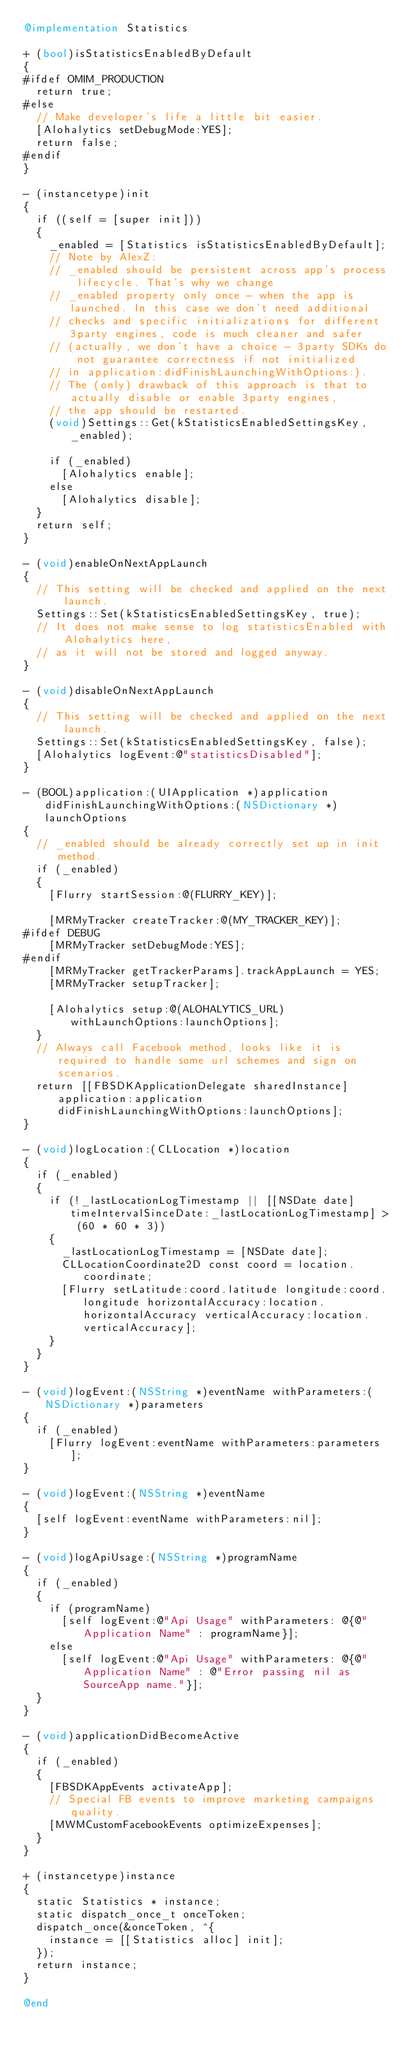Convert code to text. <code><loc_0><loc_0><loc_500><loc_500><_ObjectiveC_>@implementation Statistics

+ (bool)isStatisticsEnabledByDefault
{
#ifdef OMIM_PRODUCTION
  return true;
#else
  // Make developer's life a little bit easier.
  [Alohalytics setDebugMode:YES];
  return false;
#endif
}

- (instancetype)init
{
  if ((self = [super init]))
  {
    _enabled = [Statistics isStatisticsEnabledByDefault];
    // Note by AlexZ:
    // _enabled should be persistent across app's process lifecycle. That's why we change
    // _enabled property only once - when the app is launched. In this case we don't need additional
    // checks and specific initializations for different 3party engines, code is much cleaner and safer
    // (actually, we don't have a choice - 3party SDKs do not guarantee correctness if not initialized
    // in application:didFinishLaunchingWithOptions:).
    // The (only) drawback of this approach is that to actually disable or enable 3party engines,
    // the app should be restarted.
    (void)Settings::Get(kStatisticsEnabledSettingsKey, _enabled);

    if (_enabled)
      [Alohalytics enable];
    else
      [Alohalytics disable];
  }
  return self;
}

- (void)enableOnNextAppLaunch
{
  // This setting will be checked and applied on the next launch.
  Settings::Set(kStatisticsEnabledSettingsKey, true);
  // It does not make sense to log statisticsEnabled with Alohalytics here,
  // as it will not be stored and logged anyway.
}

- (void)disableOnNextAppLaunch
{
  // This setting will be checked and applied on the next launch.
  Settings::Set(kStatisticsEnabledSettingsKey, false);
  [Alohalytics logEvent:@"statisticsDisabled"];
}

- (BOOL)application:(UIApplication *)application didFinishLaunchingWithOptions:(NSDictionary *)launchOptions
{
  // _enabled should be already correctly set up in init method.
  if (_enabled)
  {
    [Flurry startSession:@(FLURRY_KEY)];

    [MRMyTracker createTracker:@(MY_TRACKER_KEY)];
#ifdef DEBUG
    [MRMyTracker setDebugMode:YES];
#endif
    [MRMyTracker getTrackerParams].trackAppLaunch = YES;
    [MRMyTracker setupTracker];

    [Alohalytics setup:@(ALOHALYTICS_URL) withLaunchOptions:launchOptions];
  }
  // Always call Facebook method, looks like it is required to handle some url schemes and sign on scenarios.
  return [[FBSDKApplicationDelegate sharedInstance] application:application didFinishLaunchingWithOptions:launchOptions];
}

- (void)logLocation:(CLLocation *)location
{
  if (_enabled)
  {
    if (!_lastLocationLogTimestamp || [[NSDate date] timeIntervalSinceDate:_lastLocationLogTimestamp] > (60 * 60 * 3))
    {
      _lastLocationLogTimestamp = [NSDate date];
      CLLocationCoordinate2D const coord = location.coordinate;
      [Flurry setLatitude:coord.latitude longitude:coord.longitude horizontalAccuracy:location.horizontalAccuracy verticalAccuracy:location.verticalAccuracy];
    }
  }
}

- (void)logEvent:(NSString *)eventName withParameters:(NSDictionary *)parameters
{
  if (_enabled)
    [Flurry logEvent:eventName withParameters:parameters];
}

- (void)logEvent:(NSString *)eventName
{
  [self logEvent:eventName withParameters:nil];
}

- (void)logApiUsage:(NSString *)programName
{
  if (_enabled)
  {
    if (programName)
      [self logEvent:@"Api Usage" withParameters: @{@"Application Name" : programName}];
    else
      [self logEvent:@"Api Usage" withParameters: @{@"Application Name" : @"Error passing nil as SourceApp name."}];
  }
}

- (void)applicationDidBecomeActive
{
  if (_enabled)
  {
    [FBSDKAppEvents activateApp];
    // Special FB events to improve marketing campaigns quality.
    [MWMCustomFacebookEvents optimizeExpenses];
  }
}

+ (instancetype)instance
{
  static Statistics * instance;
  static dispatch_once_t onceToken;
  dispatch_once(&onceToken, ^{
    instance = [[Statistics alloc] init];
  });
  return instance;
}

@end</code> 